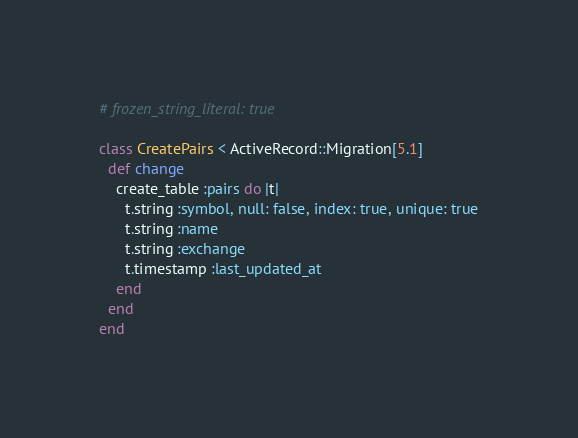Convert code to text. <code><loc_0><loc_0><loc_500><loc_500><_Ruby_># frozen_string_literal: true

class CreatePairs < ActiveRecord::Migration[5.1]
  def change
    create_table :pairs do |t|
      t.string :symbol, null: false, index: true, unique: true
      t.string :name
      t.string :exchange
      t.timestamp :last_updated_at
    end
  end
end
</code> 